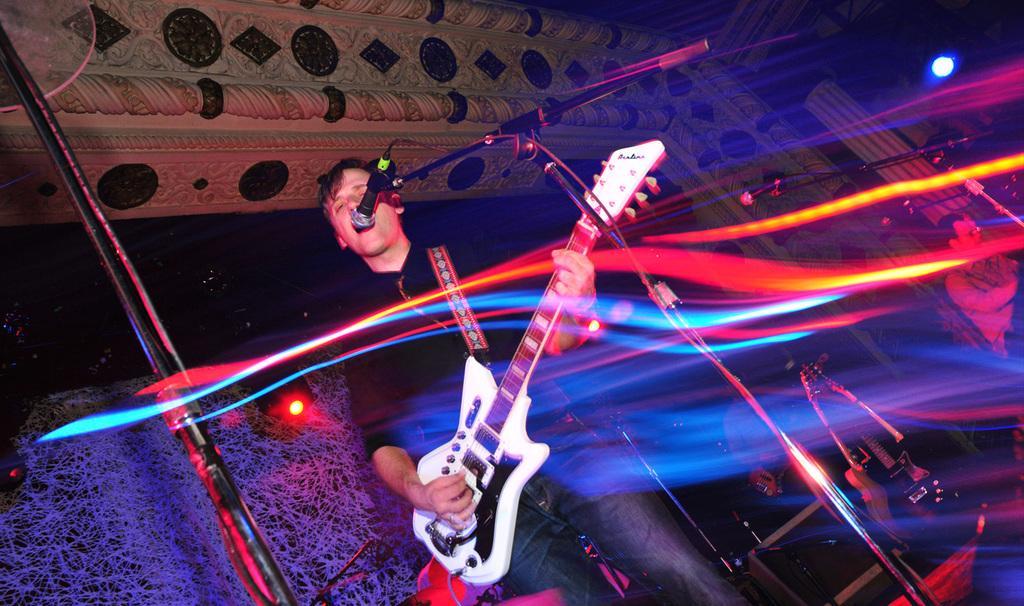Please provide a concise description of this image. There is a person standing and playing guitar, in front of this person we can see microphone with stand. In the background we can see people, guitars, microphone with stand, pillar, light. On the left side of the image we can see stand and lights. 